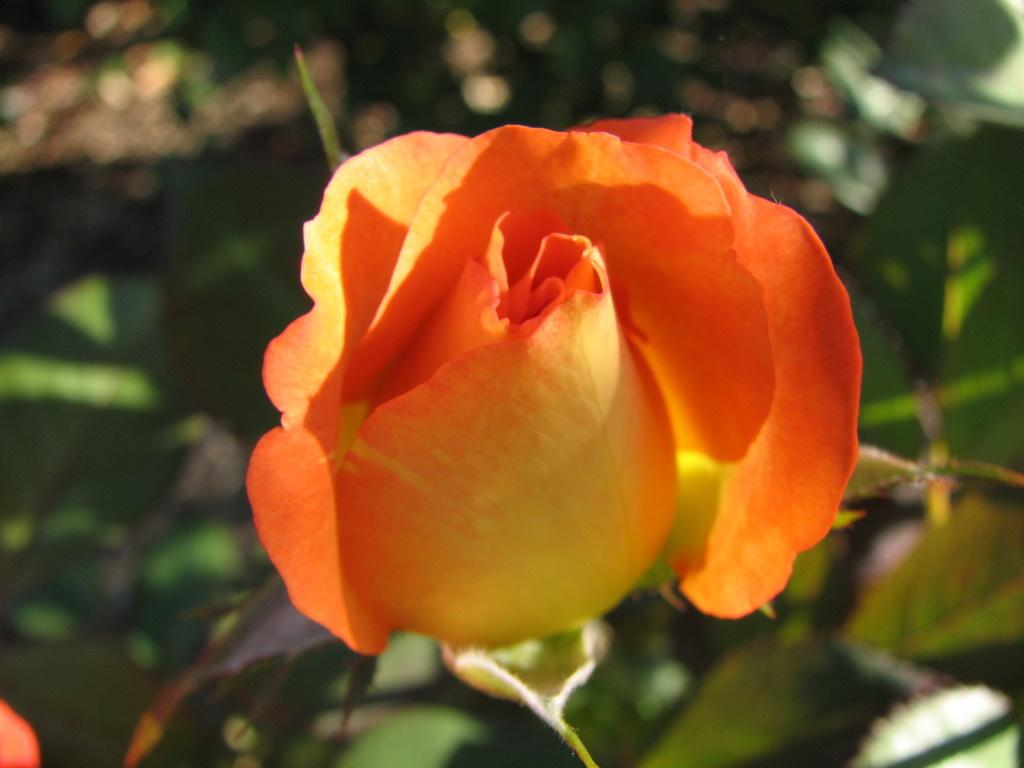What is the main subject of the image? There is a flower in the image. Can you describe the colors of the flower? The flower has orange and yellow colors. How is the flower positioned in the image? The flower is blurred in the background. What else can be seen in the image besides the flower? There are leaves visible in the image. What type of pies are being sold at the flower stand in the image? There is no mention of pies or a flower stand in the image; it only features a flower and leaves. What is the average income of the flower in the image? Flowers do not have an income, as they are living organisms and not capable of earning money. 